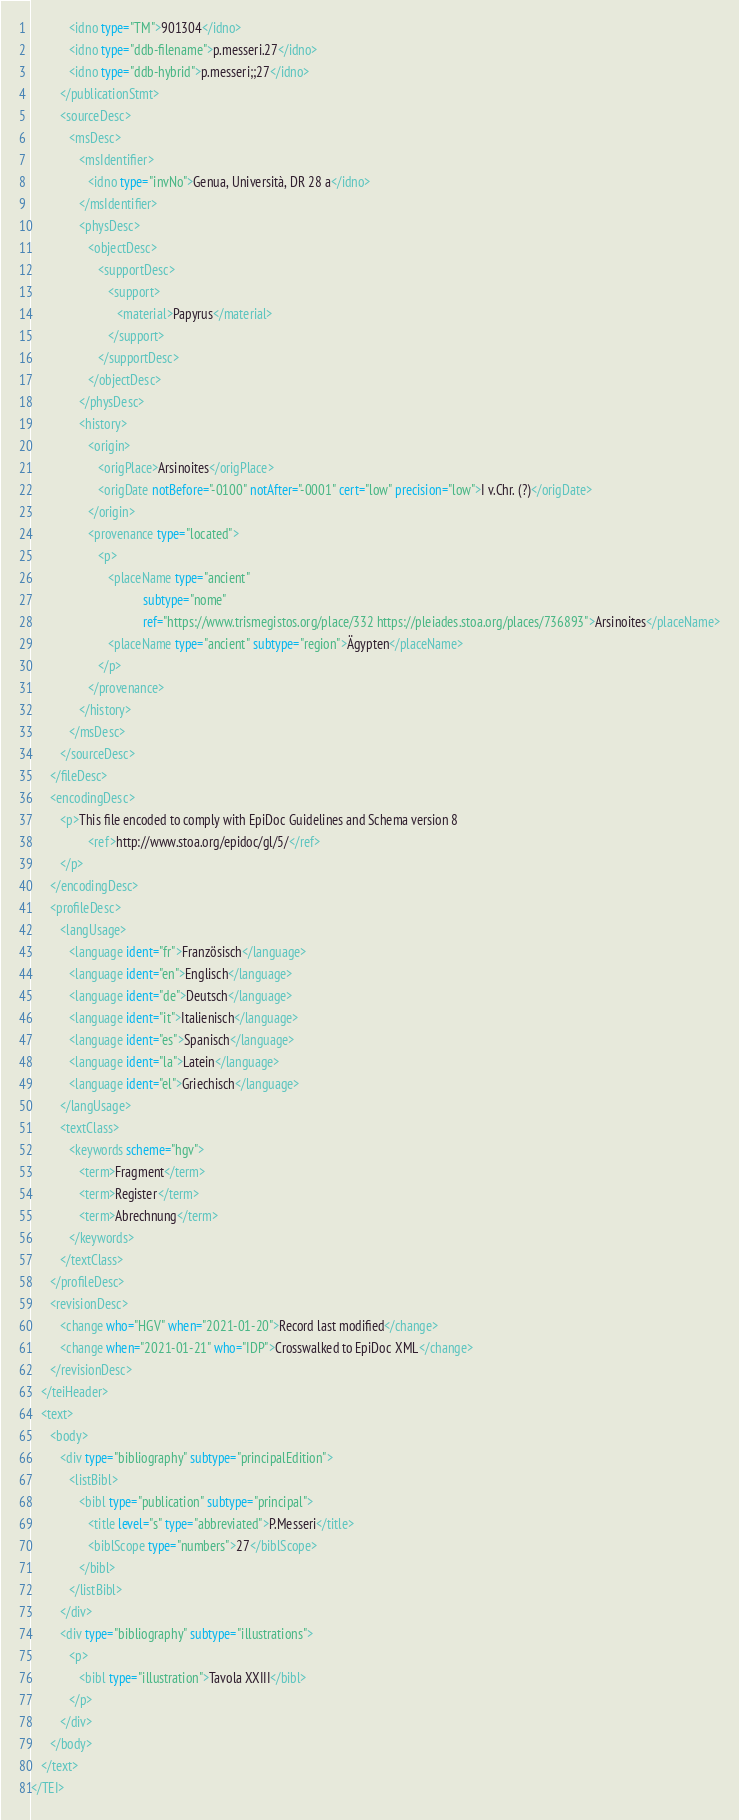Convert code to text. <code><loc_0><loc_0><loc_500><loc_500><_XML_>            <idno type="TM">901304</idno>
            <idno type="ddb-filename">p.messeri.27</idno>
            <idno type="ddb-hybrid">p.messeri;;27</idno>
         </publicationStmt>
         <sourceDesc>
            <msDesc>
               <msIdentifier>
                  <idno type="invNo">Genua, Università, DR 28 a</idno>
               </msIdentifier>
               <physDesc>
                  <objectDesc>
                     <supportDesc>
                        <support>
                           <material>Papyrus</material>
                        </support>
                     </supportDesc>
                  </objectDesc>
               </physDesc>
               <history>
                  <origin>
                     <origPlace>Arsinoites</origPlace>
                     <origDate notBefore="-0100" notAfter="-0001" cert="low" precision="low">I v.Chr. (?)</origDate>
                  </origin>
                  <provenance type="located">
                     <p>
                        <placeName type="ancient"
                                   subtype="nome"
                                   ref="https://www.trismegistos.org/place/332 https://pleiades.stoa.org/places/736893">Arsinoites</placeName>
                        <placeName type="ancient" subtype="region">Ägypten</placeName>
                     </p>
                  </provenance>
               </history>
            </msDesc>
         </sourceDesc>
      </fileDesc>
      <encodingDesc>
         <p>This file encoded to comply with EpiDoc Guidelines and Schema version 8
                  <ref>http://www.stoa.org/epidoc/gl/5/</ref>
         </p>
      </encodingDesc>
      <profileDesc>
         <langUsage>
            <language ident="fr">Französisch</language>
            <language ident="en">Englisch</language>
            <language ident="de">Deutsch</language>
            <language ident="it">Italienisch</language>
            <language ident="es">Spanisch</language>
            <language ident="la">Latein</language>
            <language ident="el">Griechisch</language>
         </langUsage>
         <textClass>
            <keywords scheme="hgv">
               <term>Fragment</term>
               <term>Register</term>
               <term>Abrechnung</term>
            </keywords>
         </textClass>
      </profileDesc>
      <revisionDesc>
         <change who="HGV" when="2021-01-20">Record last modified</change>
         <change when="2021-01-21" who="IDP">Crosswalked to EpiDoc XML</change>
      </revisionDesc>
   </teiHeader>
   <text>
      <body>
         <div type="bibliography" subtype="principalEdition">
            <listBibl>
               <bibl type="publication" subtype="principal">
                  <title level="s" type="abbreviated">P.Messeri</title>
                  <biblScope type="numbers">27</biblScope>
               </bibl>
            </listBibl>
         </div>
         <div type="bibliography" subtype="illustrations">
            <p>
               <bibl type="illustration">Tavola XXIII</bibl>
            </p>
         </div>
      </body>
   </text>
</TEI>
</code> 